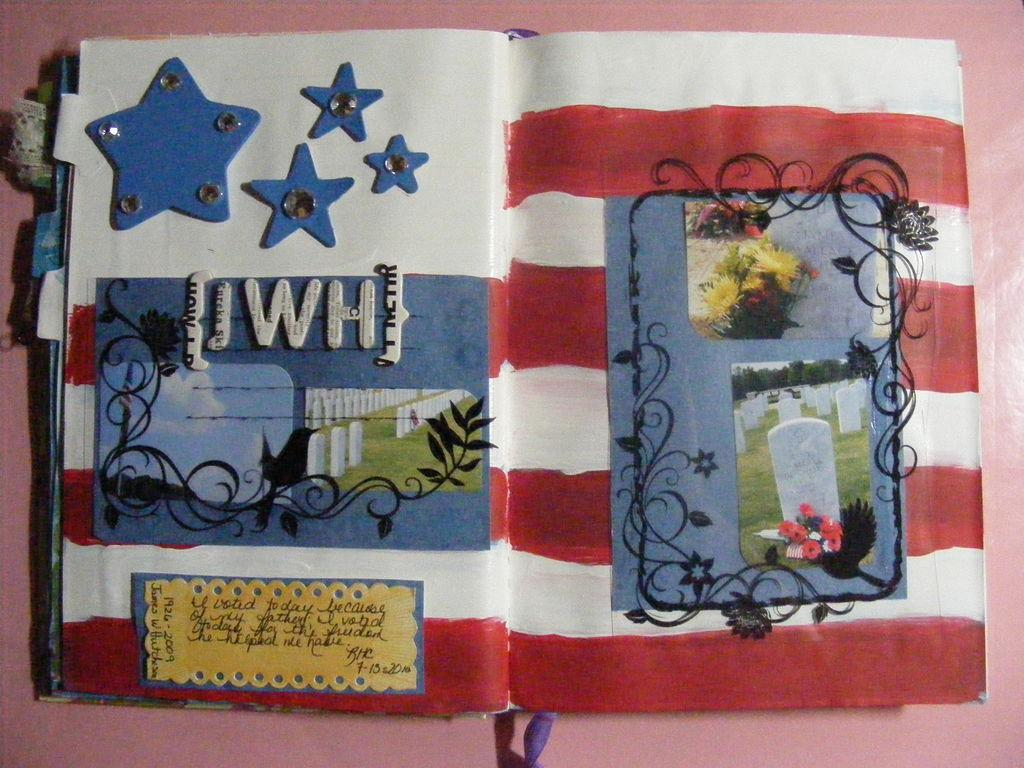What type of artwork is visible in the image? There is a wall painting in the image. Are there any other decorative elements in the image? Yes, there are posters in the image. Where might this image have been taken? The image is likely taken in a room, given the presence of a wall and posters. Can you read the note that the friend left on the coal in the image? There is no note or coal present in the image; it only features a wall painting and posters. 